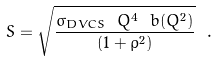<formula> <loc_0><loc_0><loc_500><loc_500>S = \sqrt { \frac { { \sigma _ { D V C S } \ Q ^ { 4 } \ b ( Q ^ { 2 } ) } } { ( 1 + \rho ^ { 2 } ) } } \ .</formula> 